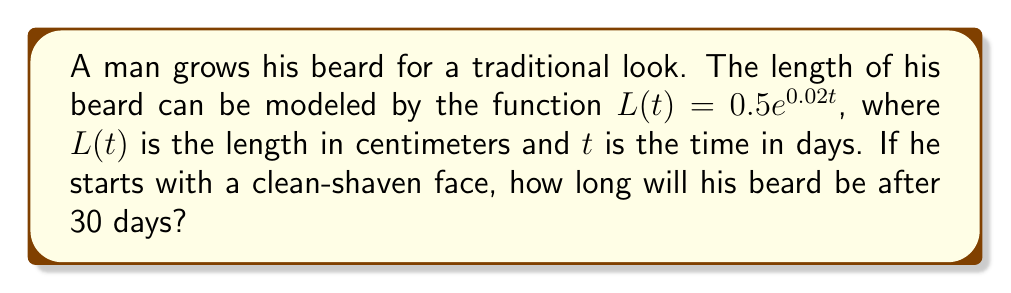Show me your answer to this math problem. To solve this problem, we'll follow these steps:

1) We are given the exponential function for beard growth:
   $L(t) = 0.5e^{0.02t}$

2) We need to find $L(30)$, as we want to know the length after 30 days.

3) Let's substitute $t = 30$ into the function:
   $L(30) = 0.5e^{0.02(30)}$

4) Simplify the exponent:
   $L(30) = 0.5e^{0.6}$

5) Now, we need to calculate this value. Using a calculator or computer:
   $0.5e^{0.6} \approx 0.9108$

6) Round to two decimal places for a practical answer.

Therefore, after 30 days, the beard will be approximately 0.91 cm long.
Answer: 0.91 cm 